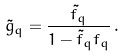Convert formula to latex. <formula><loc_0><loc_0><loc_500><loc_500>\tilde { g } _ { q } = \frac { \tilde { f } _ { q } } { 1 - \tilde { f } _ { q } f _ { q } } \, .</formula> 